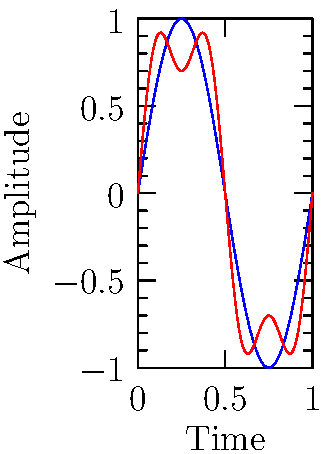Based on the waveform analysis shown in the graph, which of the following best describes the characteristic of the faulty inverter signal compared to the normal signal?

A) Higher frequency
B) Lower amplitude
C) Presence of harmonics
D) Phase shift To analyze the waveforms and identify the characteristic of the faulty inverter signal:

1. Observe the blue curve (normal signal):
   - It represents a clean sinusoidal waveform
   - Equation: $y = \sin(2\pi x)$

2. Examine the red curve (faulty signal):
   - It shows deviations from the clean sinusoidal shape
   - Contains additional oscillations superimposed on the main sine wave

3. Compare the two signals:
   - Both have the same fundamental frequency (same number of complete cycles)
   - The amplitude of the main oscillation is similar for both
   - No significant phase shift is visible between the two signals

4. Analyze the faulty signal's additional component:
   - The extra oscillations have a higher frequency than the fundamental
   - These represent harmonics added to the main signal

5. Conclude:
   - The faulty inverter signal is characterized by the presence of harmonics
   - Its equation can be approximated as: $y = \sin(2\pi x) + 0.3\sin(6\pi x)$

The presence of harmonics in the faulty signal indicates potential issues such as:
- Non-linear components in the inverter circuit
- Switching irregularities in the power electronics
- Possible degradation of filtering components

Therefore, the best description of the faulty inverter signal's characteristic is the presence of harmonics.
Answer: C) Presence of harmonics 